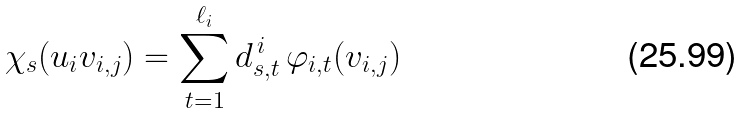<formula> <loc_0><loc_0><loc_500><loc_500>\chi _ { s } ( u _ { i } v _ { i , j } ) = \sum _ { t = 1 } ^ { \ell _ { i } } d _ { s , t } ^ { \, i } \, \varphi _ { i , t } ( v _ { i , j } )</formula> 